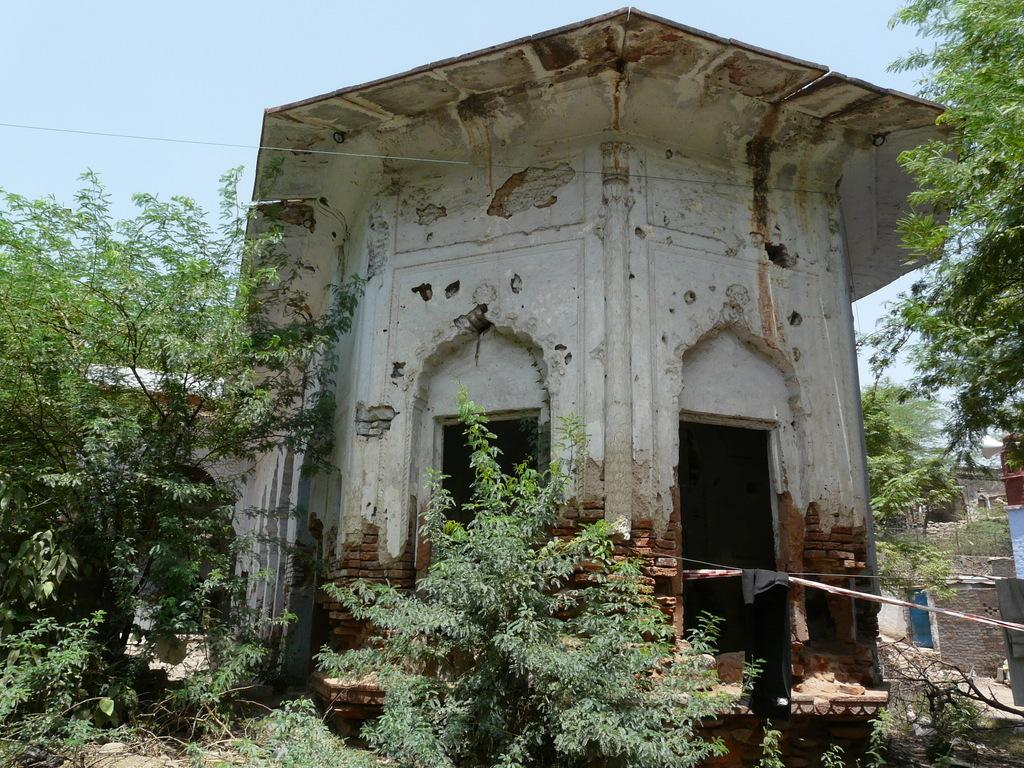What type of structure is present in the image? There is a building in the image. What other natural elements can be seen in the image? There are plants, trees, and the sky visible in the image. Can you describe the cloth in the image? There is a cloth on a pole in the image. What else is present in the image? There is a wire in the image. What can be seen in the background of the image? There are buildings visible in the background of the image, and the sky is also visible. How would you describe the sky in the image? The sky appears cloudy in the image. What type of punishment is being administered to the elbow in the image? There is no punishment or elbow present in the image. How many clovers are visible in the image? There are no clovers present in the image. 